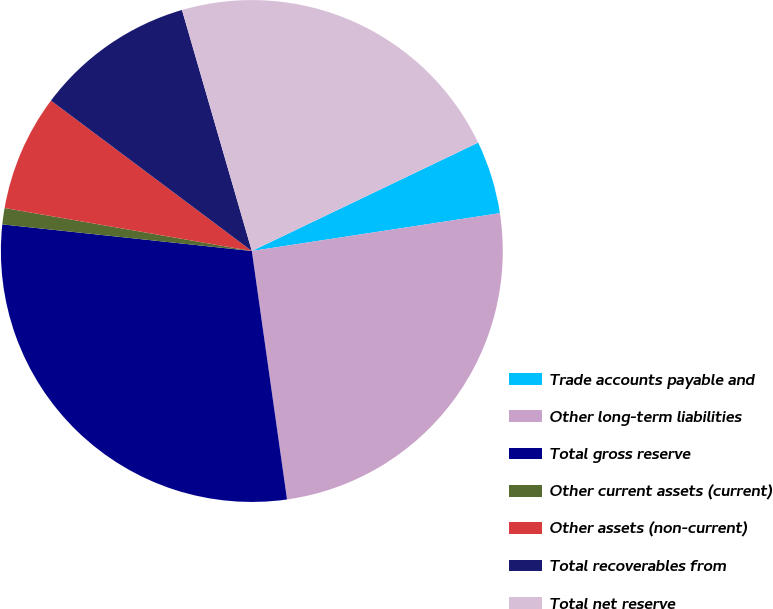Convert chart. <chart><loc_0><loc_0><loc_500><loc_500><pie_chart><fcel>Trade accounts payable and<fcel>Other long-term liabilities<fcel>Total gross reserve<fcel>Other current assets (current)<fcel>Other assets (non-current)<fcel>Total recoverables from<fcel>Total net reserve<nl><fcel>4.7%<fcel>25.17%<fcel>28.93%<fcel>1.05%<fcel>7.49%<fcel>10.28%<fcel>22.38%<nl></chart> 